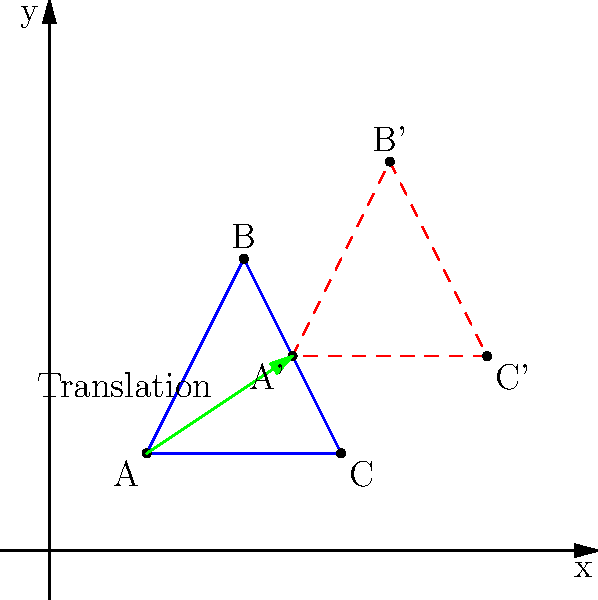An ancient geometric design found in a Mesoamerican civilization is represented by the blue triangle ABC in the coordinate plane. After studying similar designs from an Andean culture, you discover a transformation that might link the two civilizations. If the triangle is translated to the position of the red dashed triangle A'B'C', what is the translation vector that describes this transformation? To find the translation vector, we need to determine how far the original triangle has moved horizontally and vertically. We can do this by comparing the coordinates of any corresponding pair of points from the original and translated triangles.

Let's use point A (2,2) and its translated position A' (5,4):

1. Horizontal change: 5 - 2 = 3 units to the right
2. Vertical change: 4 - 2 = 2 units up

We can verify this with the other points:

For B (4,6) to B' (7,8):
- Horizontal: 7 - 4 = 3
- Vertical: 8 - 6 = 2

For C (6,2) to C' (9,4):
- Horizontal: 9 - 6 = 3
- Vertical: 4 - 2 = 2

The translation vector is consistent for all points, moving the triangle 3 units right and 2 units up.

In vector notation, this translation is represented as $\langle 3, 2 \rangle$.
Answer: $\langle 3, 2 \rangle$ 